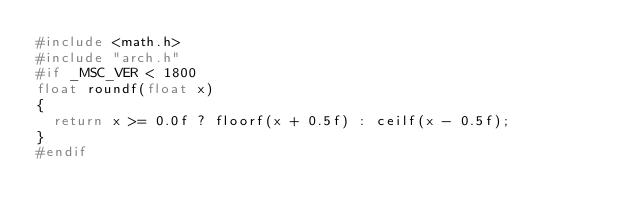Convert code to text. <code><loc_0><loc_0><loc_500><loc_500><_C++_>#include <math.h>
#include "arch.h"
#if _MSC_VER < 1800
float roundf(float x)
{
  return x >= 0.0f ? floorf(x + 0.5f) : ceilf(x - 0.5f);
}
#endif
</code> 